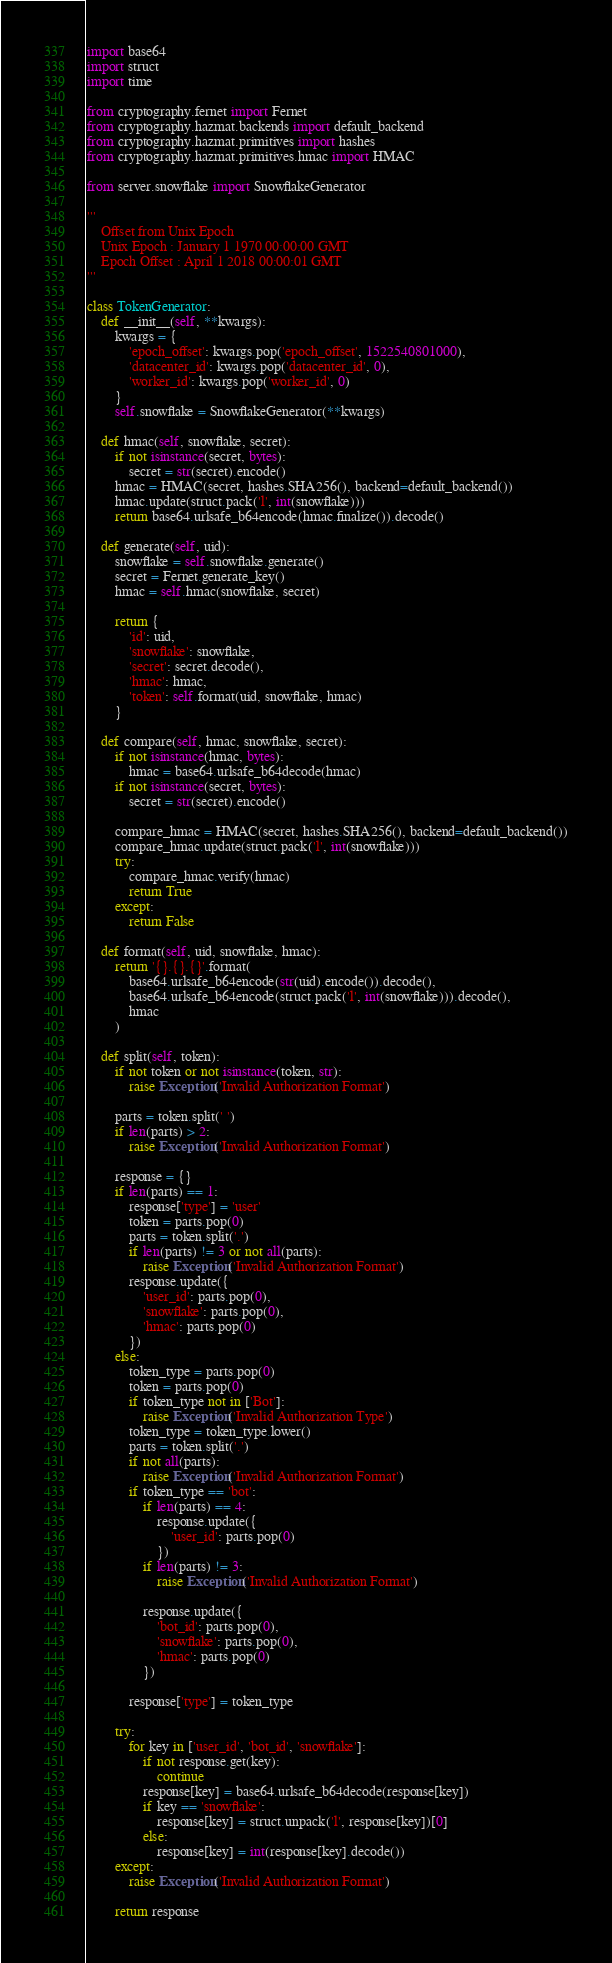Convert code to text. <code><loc_0><loc_0><loc_500><loc_500><_Python_>import base64
import struct
import time

from cryptography.fernet import Fernet
from cryptography.hazmat.backends import default_backend
from cryptography.hazmat.primitives import hashes
from cryptography.hazmat.primitives.hmac import HMAC

from server.snowflake import SnowflakeGenerator

'''
	Offset from Unix Epoch
	Unix Epoch : January 1 1970 00:00:00 GMT
	Epoch Offset : April 1 2018 00:00:01 GMT
'''

class TokenGenerator:
	def __init__(self, **kwargs):
		kwargs = {
			'epoch_offset': kwargs.pop('epoch_offset', 1522540801000),
			'datacenter_id': kwargs.pop('datacenter_id', 0),
			'worker_id': kwargs.pop('worker_id', 0)
		}
		self.snowflake = SnowflakeGenerator(**kwargs)
	
	def hmac(self, snowflake, secret):
		if not isinstance(secret, bytes):
			secret = str(secret).encode()
		hmac = HMAC(secret, hashes.SHA256(), backend=default_backend())
		hmac.update(struct.pack('l', int(snowflake)))
		return base64.urlsafe_b64encode(hmac.finalize()).decode()

	def generate(self, uid):
		snowflake = self.snowflake.generate()
		secret = Fernet.generate_key()
		hmac = self.hmac(snowflake, secret)

		return {
			'id': uid,
			'snowflake': snowflake,
			'secret': secret.decode(),
			'hmac': hmac,
			'token': self.format(uid, snowflake, hmac)
		}
	
	def compare(self, hmac, snowflake, secret):
		if not isinstance(hmac, bytes):
			hmac = base64.urlsafe_b64decode(hmac)
		if not isinstance(secret, bytes):
			secret = str(secret).encode()

		compare_hmac = HMAC(secret, hashes.SHA256(), backend=default_backend())
		compare_hmac.update(struct.pack('l', int(snowflake)))
		try:
			compare_hmac.verify(hmac)
			return True
		except:
			return False

	def format(self, uid, snowflake, hmac):
		return '{}.{}.{}'.format(
			base64.urlsafe_b64encode(str(uid).encode()).decode(),
			base64.urlsafe_b64encode(struct.pack('l', int(snowflake))).decode(),
			hmac
		)
	
	def split(self, token):
		if not token or not isinstance(token, str):
			raise Exception('Invalid Authorization Format')

		parts = token.split(' ')
		if len(parts) > 2:
			raise Exception('Invalid Authorization Format')

		response = {}
		if len(parts) == 1:
			response['type'] = 'user'
			token = parts.pop(0)
			parts = token.split('.')
			if len(parts) != 3 or not all(parts):
				raise Exception('Invalid Authorization Format')
			response.update({
				'user_id': parts.pop(0),
				'snowflake': parts.pop(0),
				'hmac': parts.pop(0)
			})
		else:
			token_type = parts.pop(0)
			token = parts.pop(0)
			if token_type not in ['Bot']:
				raise Exception('Invalid Authorization Type')
			token_type = token_type.lower()
			parts = token.split('.')
			if not all(parts):
				raise Exception('Invalid Authorization Format')
			if token_type == 'bot':
				if len(parts) == 4:
					response.update({
						'user_id': parts.pop(0)
					})
				if len(parts) != 3:
					raise Exception('Invalid Authorization Format')
				
				response.update({
					'bot_id': parts.pop(0),
					'snowflake': parts.pop(0),
					'hmac': parts.pop(0)
				})
			
			response['type'] = token_type
		
		try:
			for key in ['user_id', 'bot_id', 'snowflake']:
				if not response.get(key):
					continue
				response[key] = base64.urlsafe_b64decode(response[key])
				if key == 'snowflake':
					response[key] = struct.unpack('l', response[key])[0]
				else:
					response[key] = int(response[key].decode())
		except:
			raise Exception('Invalid Authorization Format')
		
		return response</code> 